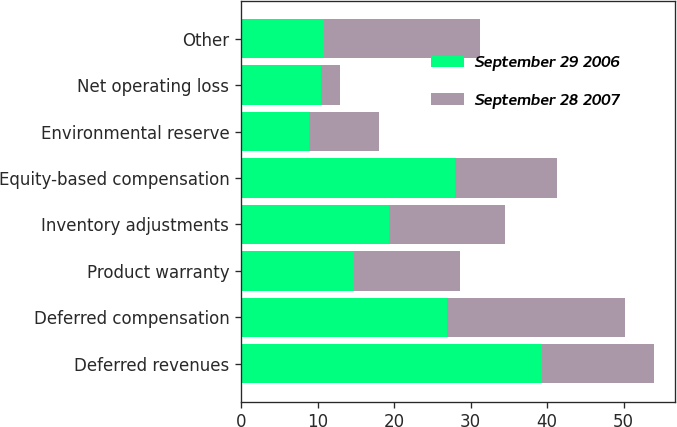Convert chart to OTSL. <chart><loc_0><loc_0><loc_500><loc_500><stacked_bar_chart><ecel><fcel>Deferred revenues<fcel>Deferred compensation<fcel>Product warranty<fcel>Inventory adjustments<fcel>Equity-based compensation<fcel>Environmental reserve<fcel>Net operating loss<fcel>Other<nl><fcel>September 29 2006<fcel>39.3<fcel>26.9<fcel>14.7<fcel>19.3<fcel>27.9<fcel>8.9<fcel>10.4<fcel>10.9<nl><fcel>September 28 2007<fcel>14.7<fcel>23.3<fcel>13.9<fcel>15.2<fcel>13.4<fcel>9.1<fcel>2.5<fcel>20.3<nl></chart> 